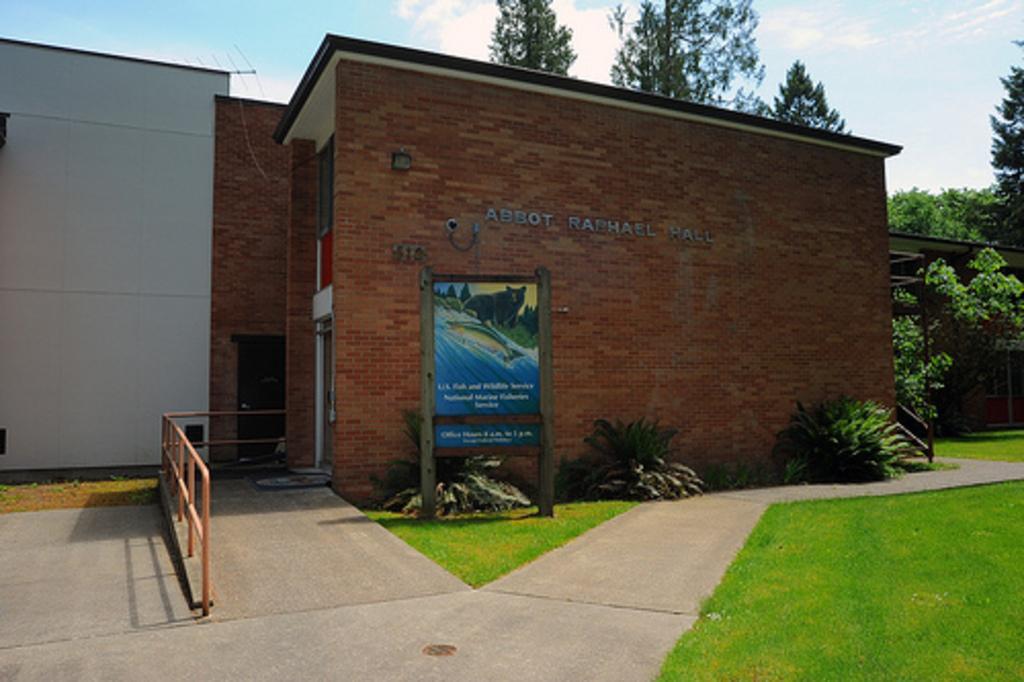Please provide a concise description of this image. In this image we can see a building, there we can see a door, window, fence, meat rods, fence, pavement, a wooden frame, grass, a few plants, trees, there we can see a name on the building, camera and some clouds in the sky. 